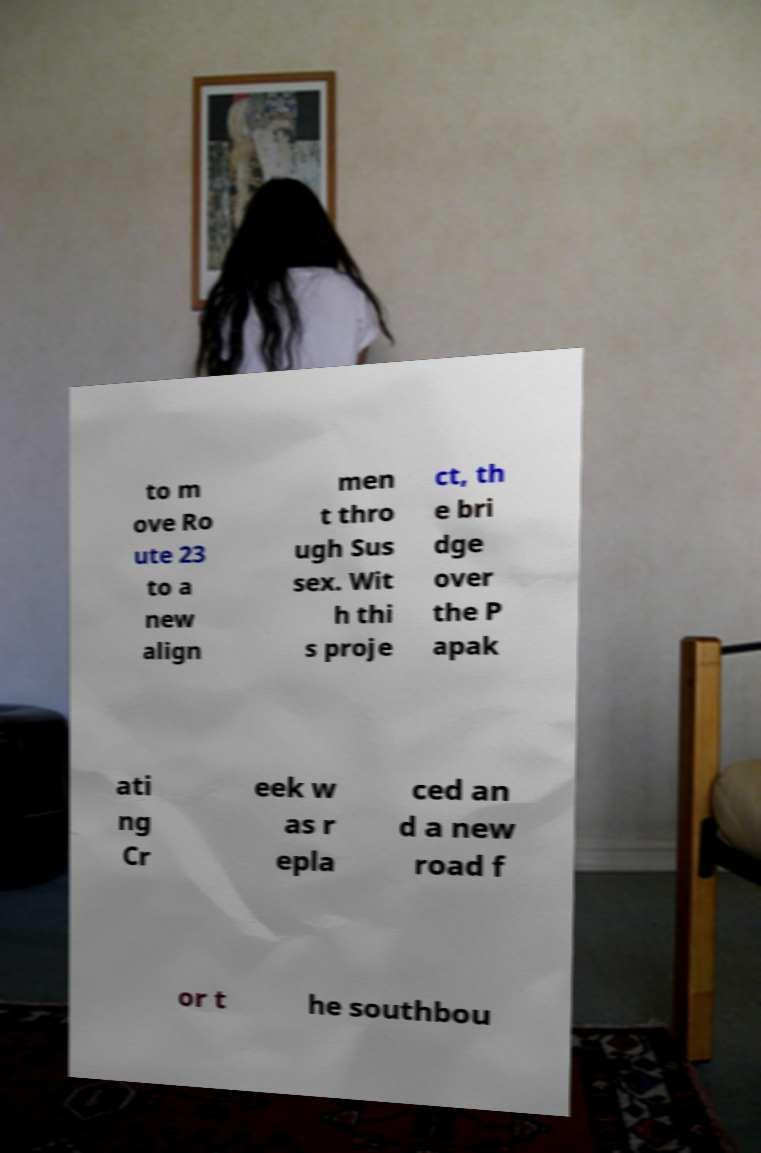Please identify and transcribe the text found in this image. to m ove Ro ute 23 to a new align men t thro ugh Sus sex. Wit h thi s proje ct, th e bri dge over the P apak ati ng Cr eek w as r epla ced an d a new road f or t he southbou 